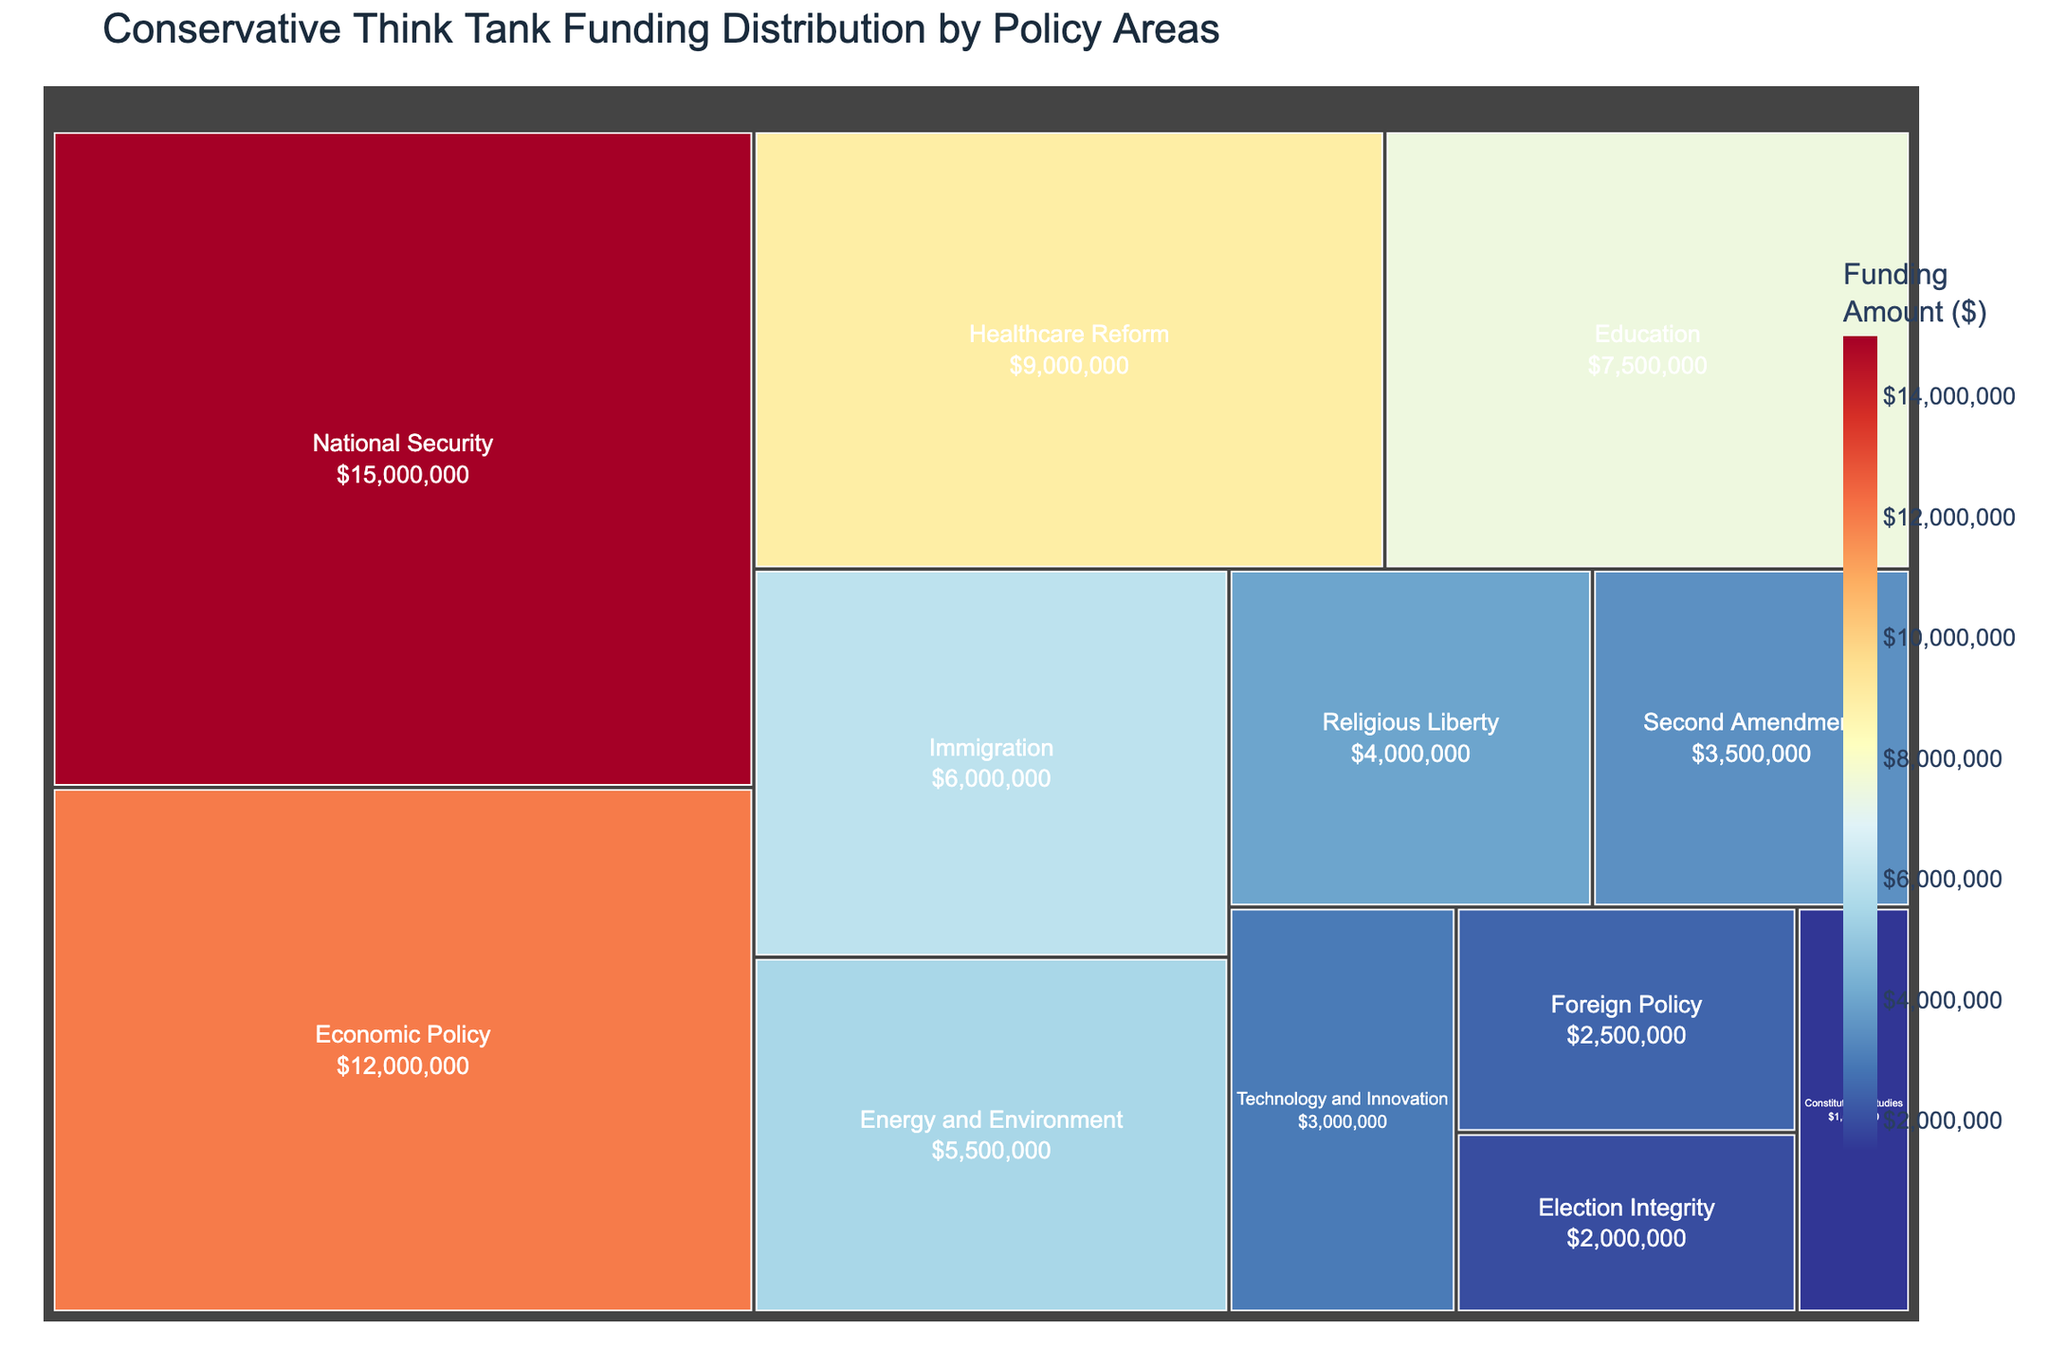What is the total funding amount for National Security policy area? The largest section in the treemap is labeled "National Security" with a funding amount of $15,000,000.
Answer: $15,000,000 Which policy area receives the least amount of funding? The smallest section in the treemap is labeled "Constitutional Studies" with a funding amount of $1,500,000.
Answer: Constitutional Studies How much more funding does National Security receive compared to Second Amendment? National Security receives $15,000,000 and Second Amendment receives $3,500,000. The difference is $15,000,000 - $3,500,000 = $11,500,000.
Answer: $11,500,000 What is the combined funding amount for Economic Policy and Healthcare Reform? Economic Policy has $12,000,000 and Healthcare Reform has $9,000,000. The combined amount is $12,000,000 + $9,000,000 = $21,000,000.
Answer: $21,000,000 How many policy areas receive more than $5,000,000 in funding? By observing the treemap, the policy areas with more than $5,000,000 in funding are National Security, Economic Policy, Healthcare Reform, Education, Immigration, and Energy and Environment. There are 6 such areas.
Answer: 6 Which policy area receives the most funding for technology-related initiatives? The policy area "Technology and Innovation" is dedicated to technology-related initiatives and receives $3,000,000.
Answer: Technology and Innovation Compare the funding amount for Education and Immigration. Which one gets more, and by how much? Education receives $7,500,000 and Immigration receives $6,000,000. Education gets more by $7,500,000 - $6,000,000 = $1,500,000.
Answer: Education by $1,500,000 What is the funding difference between the top two funded policy areas? The top two funded areas are National Security ($15,000,000) and Economic Policy ($12,000,000). The difference is $15,000,000 - $12,000,000 = $3,000,000.
Answer: $3,000,000 What fraction of the total funding goes to Foreign Policy? The total funding is the sum of all funding amounts. The sum is $15,000,000 + $12,000,000 + $9,000,000 + $7,500,000 + $6,000,000 + $5,500,000 + $4,000,000 + $3,500,000 + $3,000,000 + $2,500,000 + $2,000,000 + $1,500,000 = $71,500,000. The fraction for Foreign Policy is $2,500,000 / $71,500,000 = 1/28.6.
Answer: 1/28.6 What is the title of the treemap? The title displayed at the top of the treemap is "Conservative Think Tank Funding Distribution by Policy Areas".
Answer: Conservative Think Tank Funding Distribution by Policy Areas 